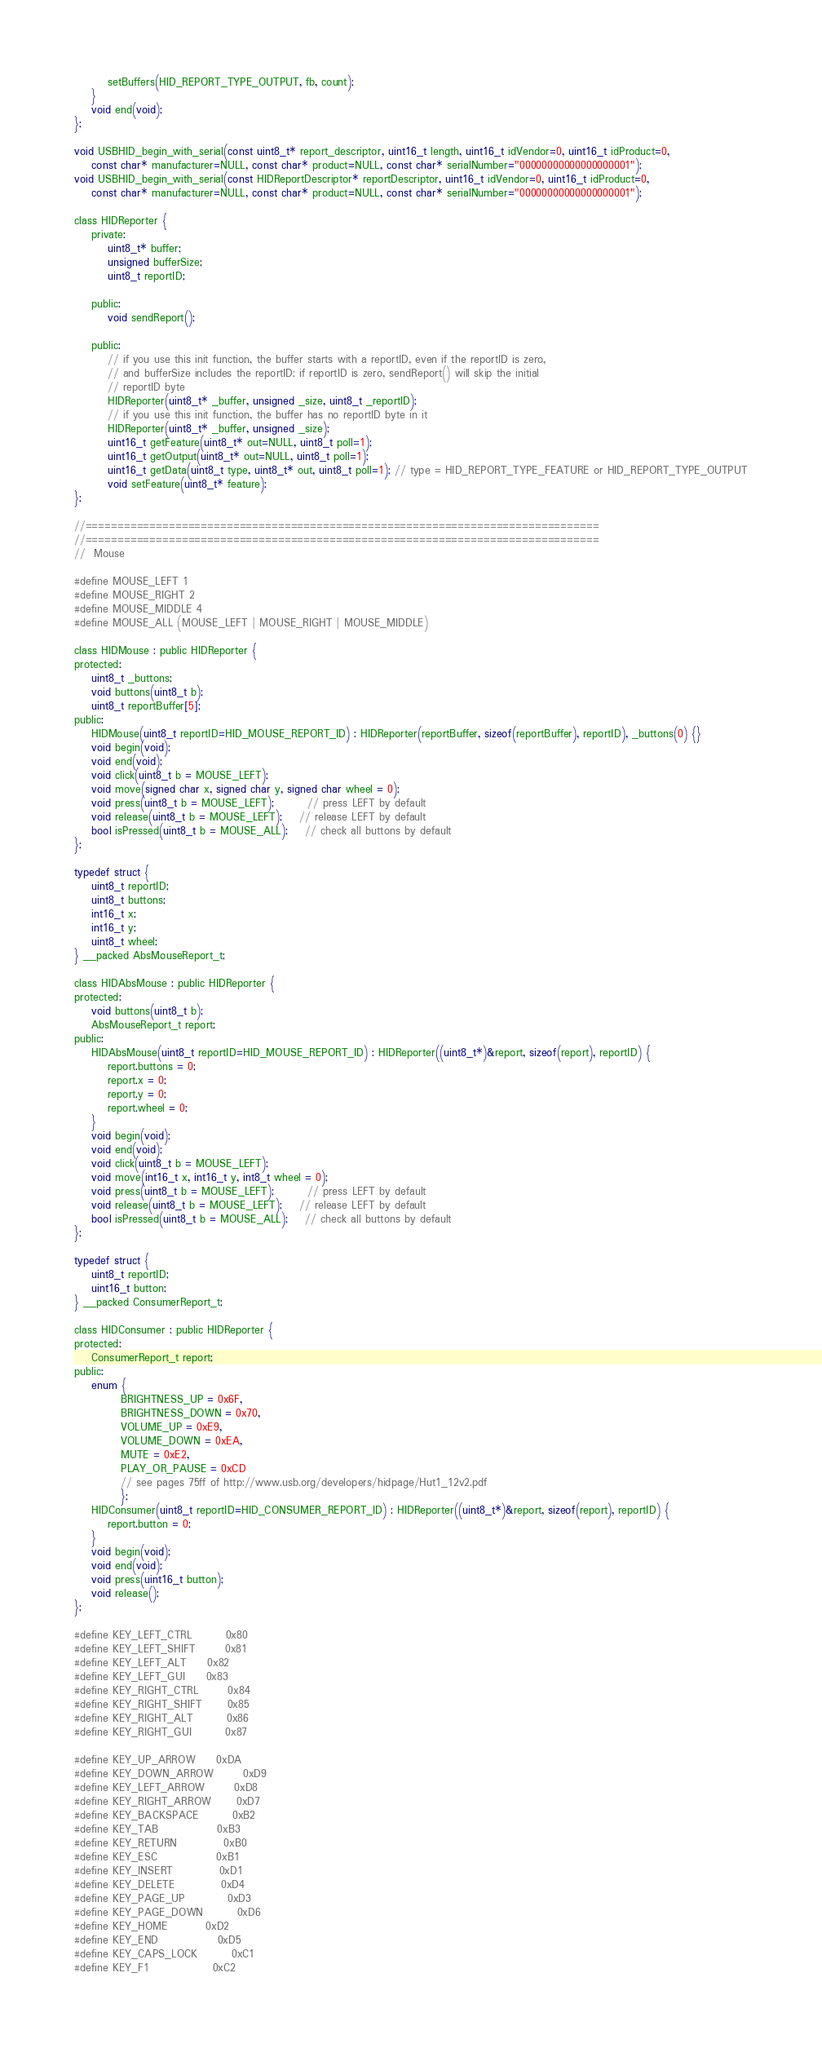<code> <loc_0><loc_0><loc_500><loc_500><_C_>        setBuffers(HID_REPORT_TYPE_OUTPUT, fb, count);
    }     
    void end(void);
};

void USBHID_begin_with_serial(const uint8_t* report_descriptor, uint16_t length, uint16_t idVendor=0, uint16_t idProduct=0,
	const char* manufacturer=NULL, const char* product=NULL, const char* serialNumber="00000000000000000001");
void USBHID_begin_with_serial(const HIDReportDescriptor* reportDescriptor, uint16_t idVendor=0, uint16_t idProduct=0,
	const char* manufacturer=NULL, const char* product=NULL, const char* serialNumber="00000000000000000001");

class HIDReporter {
    private:
        uint8_t* buffer;
        unsigned bufferSize;
        uint8_t reportID;
        
    public:
        void sendReport(); 
        
    public:
        // if you use this init function, the buffer starts with a reportID, even if the reportID is zero,
        // and bufferSize includes the reportID; if reportID is zero, sendReport() will skip the initial
        // reportID byte
        HIDReporter(uint8_t* _buffer, unsigned _size, uint8_t _reportID);
        // if you use this init function, the buffer has no reportID byte in it
        HIDReporter(uint8_t* _buffer, unsigned _size);
        uint16_t getFeature(uint8_t* out=NULL, uint8_t poll=1);
        uint16_t getOutput(uint8_t* out=NULL, uint8_t poll=1);
        uint16_t getData(uint8_t type, uint8_t* out, uint8_t poll=1); // type = HID_REPORT_TYPE_FEATURE or HID_REPORT_TYPE_OUTPUT
        void setFeature(uint8_t* feature);
};

//================================================================================
//================================================================================
//	Mouse

#define MOUSE_LEFT 1
#define MOUSE_RIGHT 2
#define MOUSE_MIDDLE 4
#define MOUSE_ALL (MOUSE_LEFT | MOUSE_RIGHT | MOUSE_MIDDLE)

class HIDMouse : public HIDReporter {
protected:
    uint8_t _buttons;
	void buttons(uint8_t b);
    uint8_t reportBuffer[5];
public:
	HIDMouse(uint8_t reportID=HID_MOUSE_REPORT_ID) : HIDReporter(reportBuffer, sizeof(reportBuffer), reportID), _buttons(0) {}
	void begin(void);
	void end(void);
	void click(uint8_t b = MOUSE_LEFT);
	void move(signed char x, signed char y, signed char wheel = 0);
	void press(uint8_t b = MOUSE_LEFT);		// press LEFT by default
	void release(uint8_t b = MOUSE_LEFT);	// release LEFT by default
	bool isPressed(uint8_t b = MOUSE_ALL);	// check all buttons by default
};

typedef struct {
    uint8_t reportID;
    uint8_t buttons;
    int16_t x;
    int16_t y;
    uint8_t wheel;
} __packed AbsMouseReport_t;

class HIDAbsMouse : public HIDReporter {
protected:
	void buttons(uint8_t b);
    AbsMouseReport_t report;
public:
	HIDAbsMouse(uint8_t reportID=HID_MOUSE_REPORT_ID) : HIDReporter((uint8_t*)&report, sizeof(report), reportID) {
        report.buttons = 0;
        report.x = 0;
        report.y = 0;
        report.wheel = 0;
    }
	void begin(void);
	void end(void);
	void click(uint8_t b = MOUSE_LEFT);
	void move(int16_t x, int16_t y, int8_t wheel = 0);
	void press(uint8_t b = MOUSE_LEFT);		// press LEFT by default
	void release(uint8_t b = MOUSE_LEFT);	// release LEFT by default
	bool isPressed(uint8_t b = MOUSE_ALL);	// check all buttons by default
};

typedef struct {
    uint8_t reportID;
    uint16_t button;
} __packed ConsumerReport_t;

class HIDConsumer : public HIDReporter {
protected:
    ConsumerReport_t report;
public:
    enum { 
           BRIGHTNESS_UP = 0x6F, 
           BRIGHTNESS_DOWN = 0x70, 
           VOLUME_UP = 0xE9, 
           VOLUME_DOWN = 0xEA,
           MUTE = 0xE2, 
           PLAY_OR_PAUSE = 0xCD
           // see pages 75ff of http://www.usb.org/developers/hidpage/Hut1_12v2.pdf
           };
	HIDConsumer(uint8_t reportID=HID_CONSUMER_REPORT_ID) : HIDReporter((uint8_t*)&report, sizeof(report), reportID) {
        report.button = 0;
    }
	void begin(void);
	void end(void);
    void press(uint16_t button);
    void release();
};

#define KEY_LEFT_CTRL		0x80
#define KEY_LEFT_SHIFT		0x81
#define KEY_LEFT_ALT		0x82
#define KEY_LEFT_GUI		0x83
#define KEY_RIGHT_CTRL		0x84
#define KEY_RIGHT_SHIFT		0x85
#define KEY_RIGHT_ALT		0x86
#define KEY_RIGHT_GUI		0x87

#define KEY_UP_ARROW		0xDA
#define KEY_DOWN_ARROW		0xD9
#define KEY_LEFT_ARROW		0xD8
#define KEY_RIGHT_ARROW		0xD7
#define KEY_BACKSPACE		0xB2
#define KEY_TAB				0xB3
#define KEY_RETURN			0xB0
#define KEY_ESC				0xB1
#define KEY_INSERT			0xD1
#define KEY_DELETE			0xD4
#define KEY_PAGE_UP			0xD3
#define KEY_PAGE_DOWN		0xD6
#define KEY_HOME			0xD2
#define KEY_END				0xD5
#define KEY_CAPS_LOCK		0xC1
#define KEY_F1				0xC2</code> 